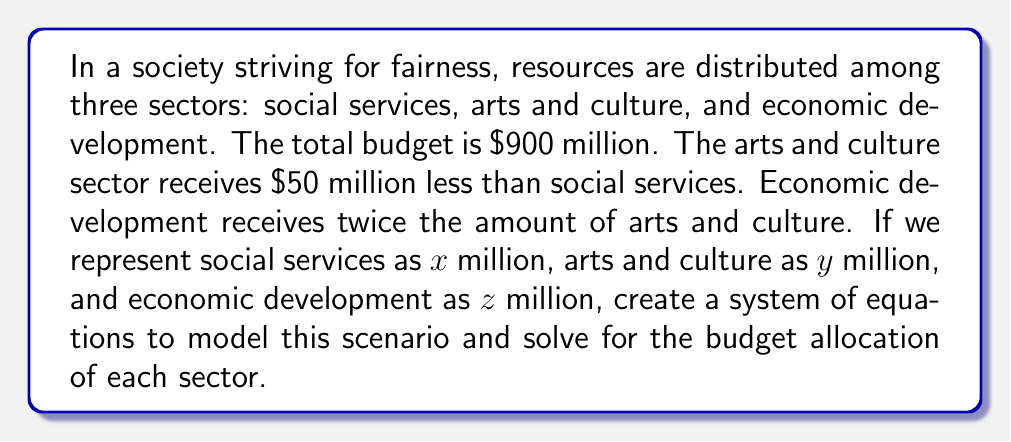Teach me how to tackle this problem. Let's approach this step-by-step:

1) First, we can set up our system of equations based on the given information:

   $$x + y + z = 900$$ (total budget)
   $$y = x - 50$$ (arts and culture receives $50 million less than social services)
   $$z = 2y$$ (economic development receives twice the amount of arts and culture)

2) We can substitute the second equation into the first:

   $$x + (x - 50) + z = 900$$

3) Now, let's substitute the third equation:

   $$x + (x - 50) + 2(x - 50) = 900$$

4) Simplify:

   $$x + x - 50 + 2x - 100 = 900$$
   $$4x - 150 = 900$$

5) Solve for x:

   $$4x = 1050$$
   $$x = 262.5$$

6) Now that we know x, we can find y and z:

   $$y = x - 50 = 262.5 - 50 = 212.5$$
   $$z = 2y = 2(212.5) = 425$$

7) Let's verify our solution:

   $$262.5 + 212.5 + 425 = 900$$

This solution represents a fair distribution that adheres to the given constraints while promoting arts and culture, which aligns with the persona of an artist who uses art to express political views.
Answer: Social Services: $262.5 million
Arts and Culture: $212.5 million
Economic Development: $425 million 